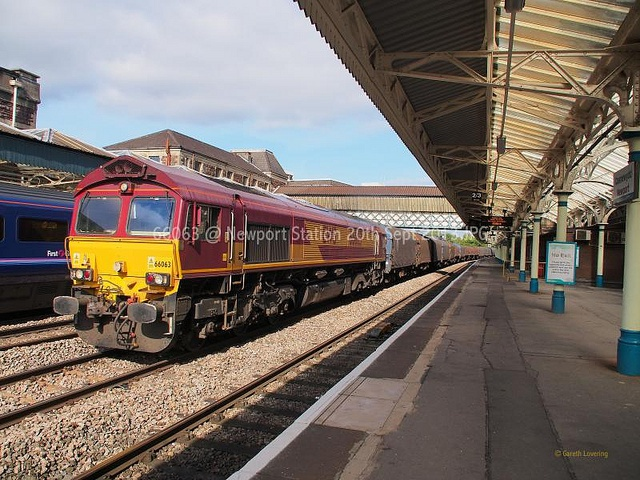Describe the objects in this image and their specific colors. I can see train in lightgray, black, maroon, gray, and brown tones and train in lightgray, black, navy, and gray tones in this image. 